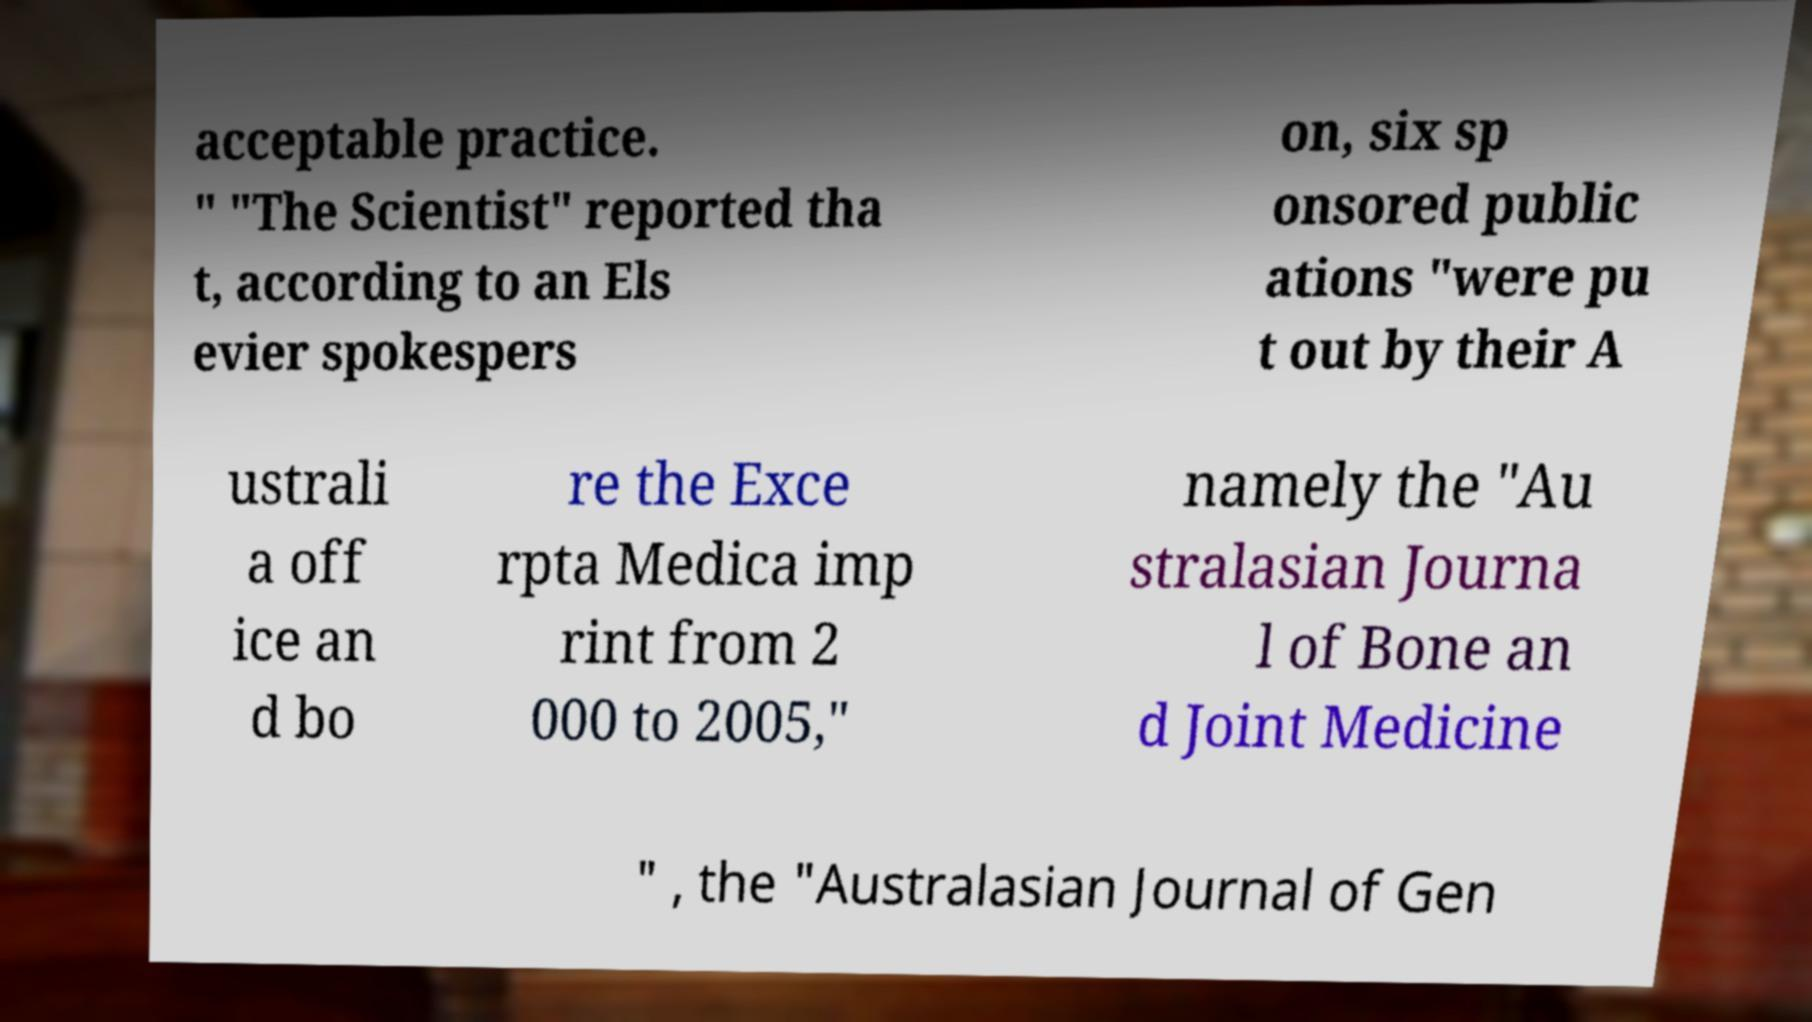Could you extract and type out the text from this image? acceptable practice. " "The Scientist" reported tha t, according to an Els evier spokespers on, six sp onsored public ations "were pu t out by their A ustrali a off ice an d bo re the Exce rpta Medica imp rint from 2 000 to 2005," namely the "Au stralasian Journa l of Bone an d Joint Medicine " , the "Australasian Journal of Gen 